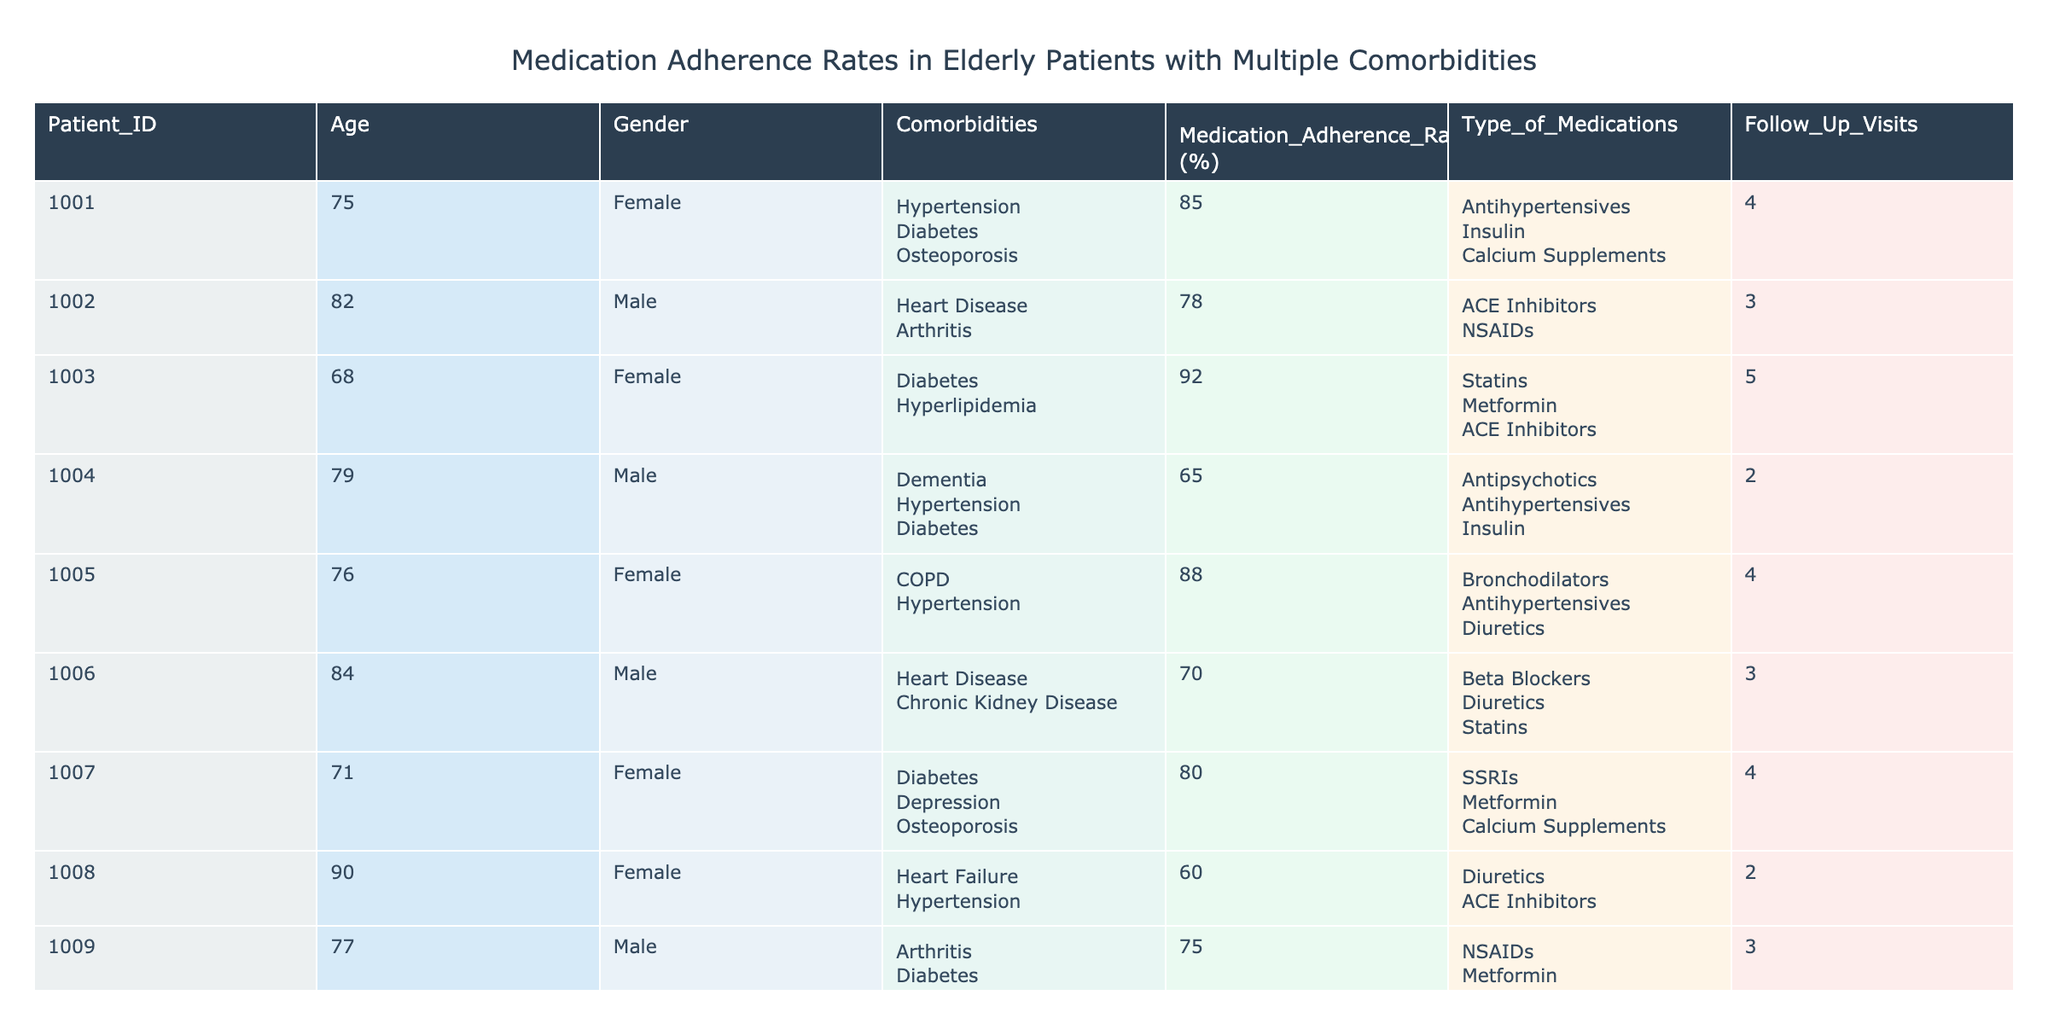What is the medication adherence rate for the patient with the highest age? The oldest patient in the table is patient ID 1008, who is 90 years old. Referring to the table, their medication adherence rate is 60%.
Answer: 60% What type of medications does the patient with ID 1004 take? Looking at patient ID 1004 in the table, the listed types of medications are antipsychotics, antihypertensives, and insulin.
Answer: Antipsychotics; Antihypertensives; Insulin What is the average medication adherence rate of female patients? The female patients are patient IDs 1001, 1003, 1005, 1007, and 1010. Their adherence rates are 85%, 92%, 88%, 80%, and 90%. Summing these gives 85 + 92 + 88 + 80 + 90 = 425, and then dividing by 5 (the number of patients) gives an average of 85.
Answer: 85 Is there a patient with a medication adherence rate below 70%? By evaluating each patient's adherence rate listed in the table, patient ID 1004 and patient ID 1008 have adherence rates of 65% and 60%, respectively, which are both below 70%.
Answer: Yes What percentage of patients have multiple comorbidities? Out of the 10 patients listed, all but patient ID 1010 have multiple comorbidities. That gives us 9 patients with multiple comorbidities out of 10 total. Therefore, the percentage is (9/10) * 100 = 90%.
Answer: 90% 